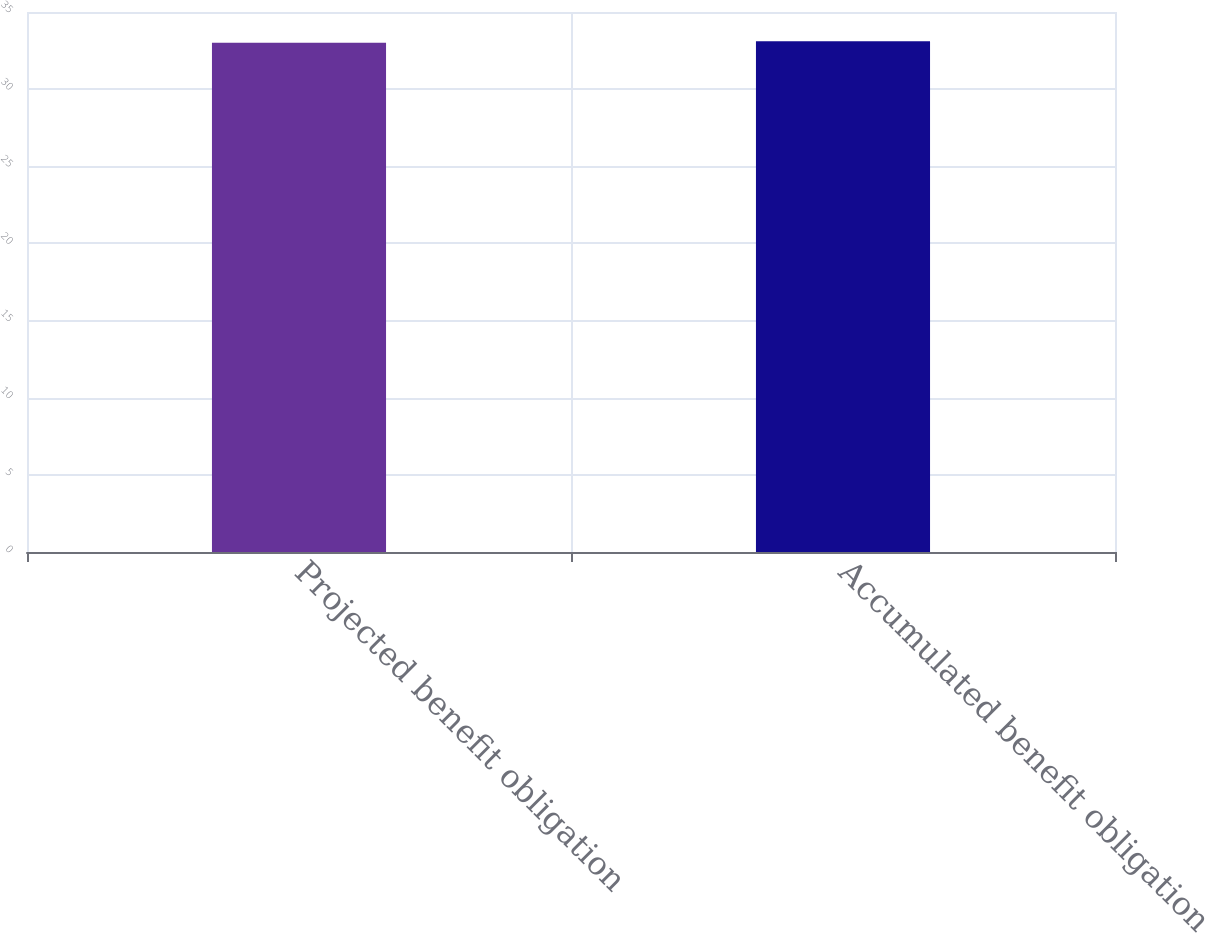Convert chart. <chart><loc_0><loc_0><loc_500><loc_500><bar_chart><fcel>Projected benefit obligation<fcel>Accumulated benefit obligation<nl><fcel>33<fcel>33.1<nl></chart> 